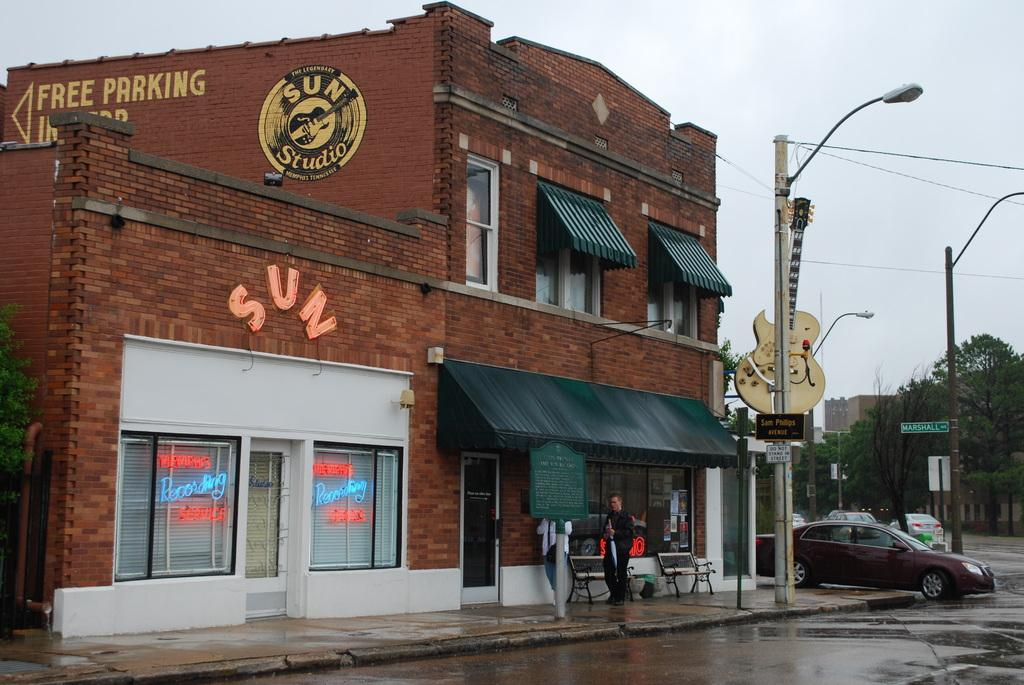<image>
Summarize the visual content of the image. A brick building with the word sun in front and a car park on the right side. 